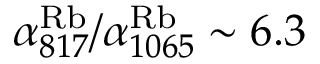<formula> <loc_0><loc_0><loc_500><loc_500>\alpha _ { 8 1 7 } ^ { R b } / \alpha _ { 1 0 6 5 } ^ { R b } \sim 6 . 3</formula> 